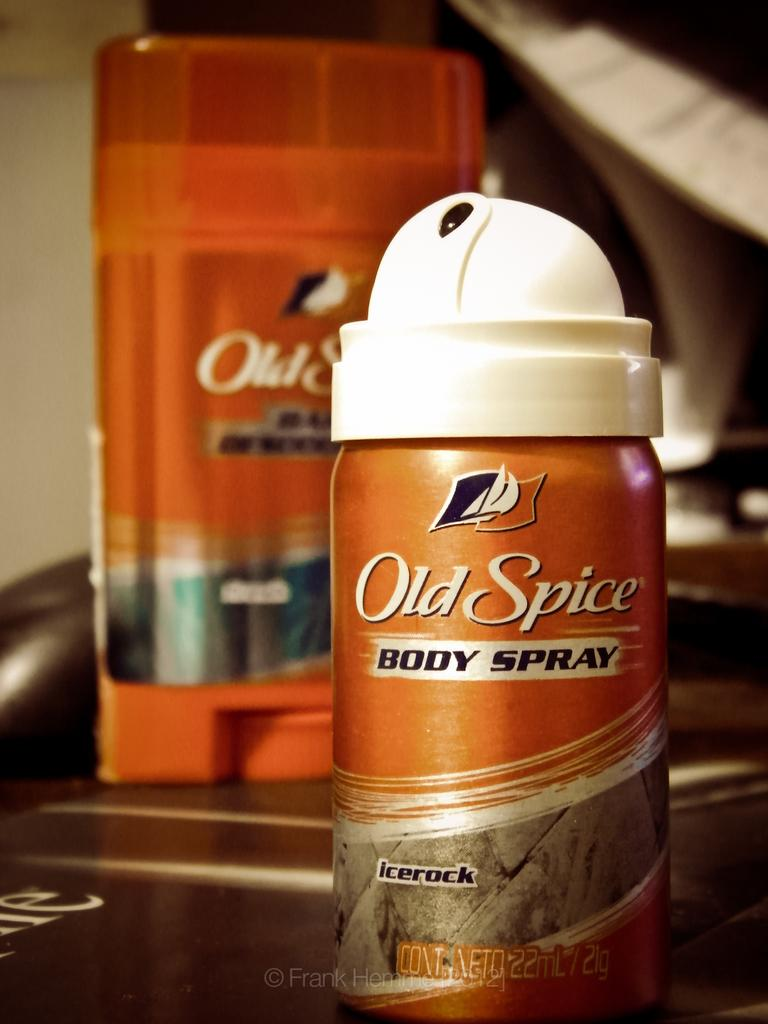<image>
Describe the image concisely. Old Spice Body Spray comes in the fragrance 'icerock'. 